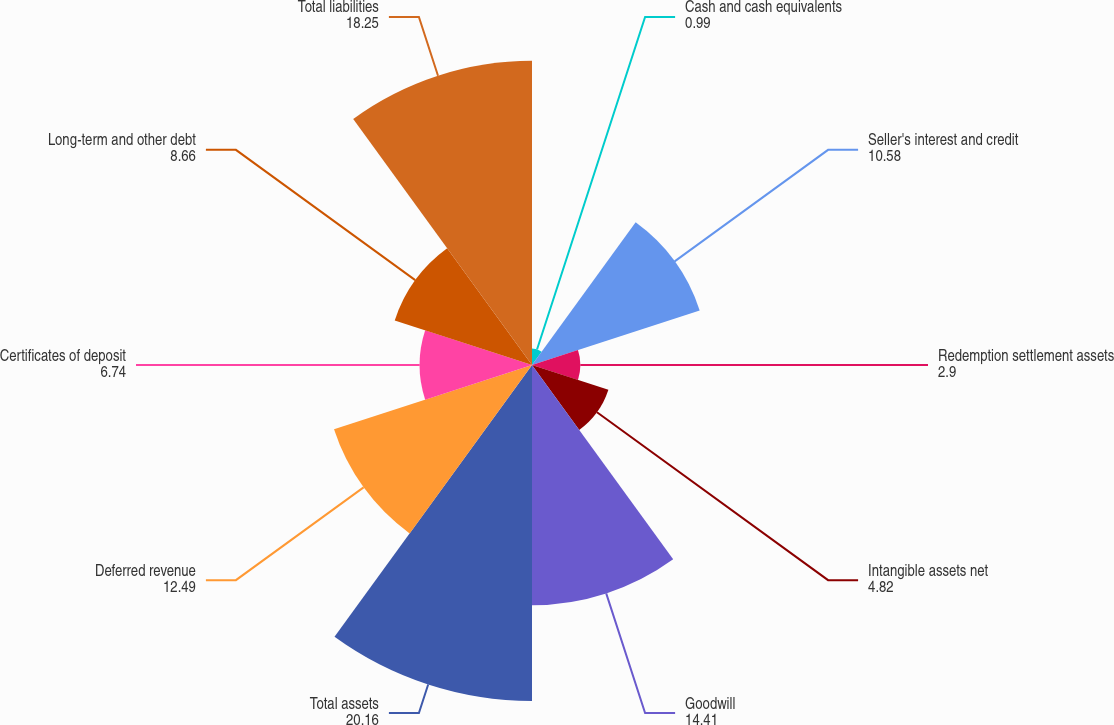<chart> <loc_0><loc_0><loc_500><loc_500><pie_chart><fcel>Cash and cash equivalents<fcel>Seller's interest and credit<fcel>Redemption settlement assets<fcel>Intangible assets net<fcel>Goodwill<fcel>Total assets<fcel>Deferred revenue<fcel>Certificates of deposit<fcel>Long-term and other debt<fcel>Total liabilities<nl><fcel>0.99%<fcel>10.58%<fcel>2.9%<fcel>4.82%<fcel>14.41%<fcel>20.16%<fcel>12.49%<fcel>6.74%<fcel>8.66%<fcel>18.25%<nl></chart> 